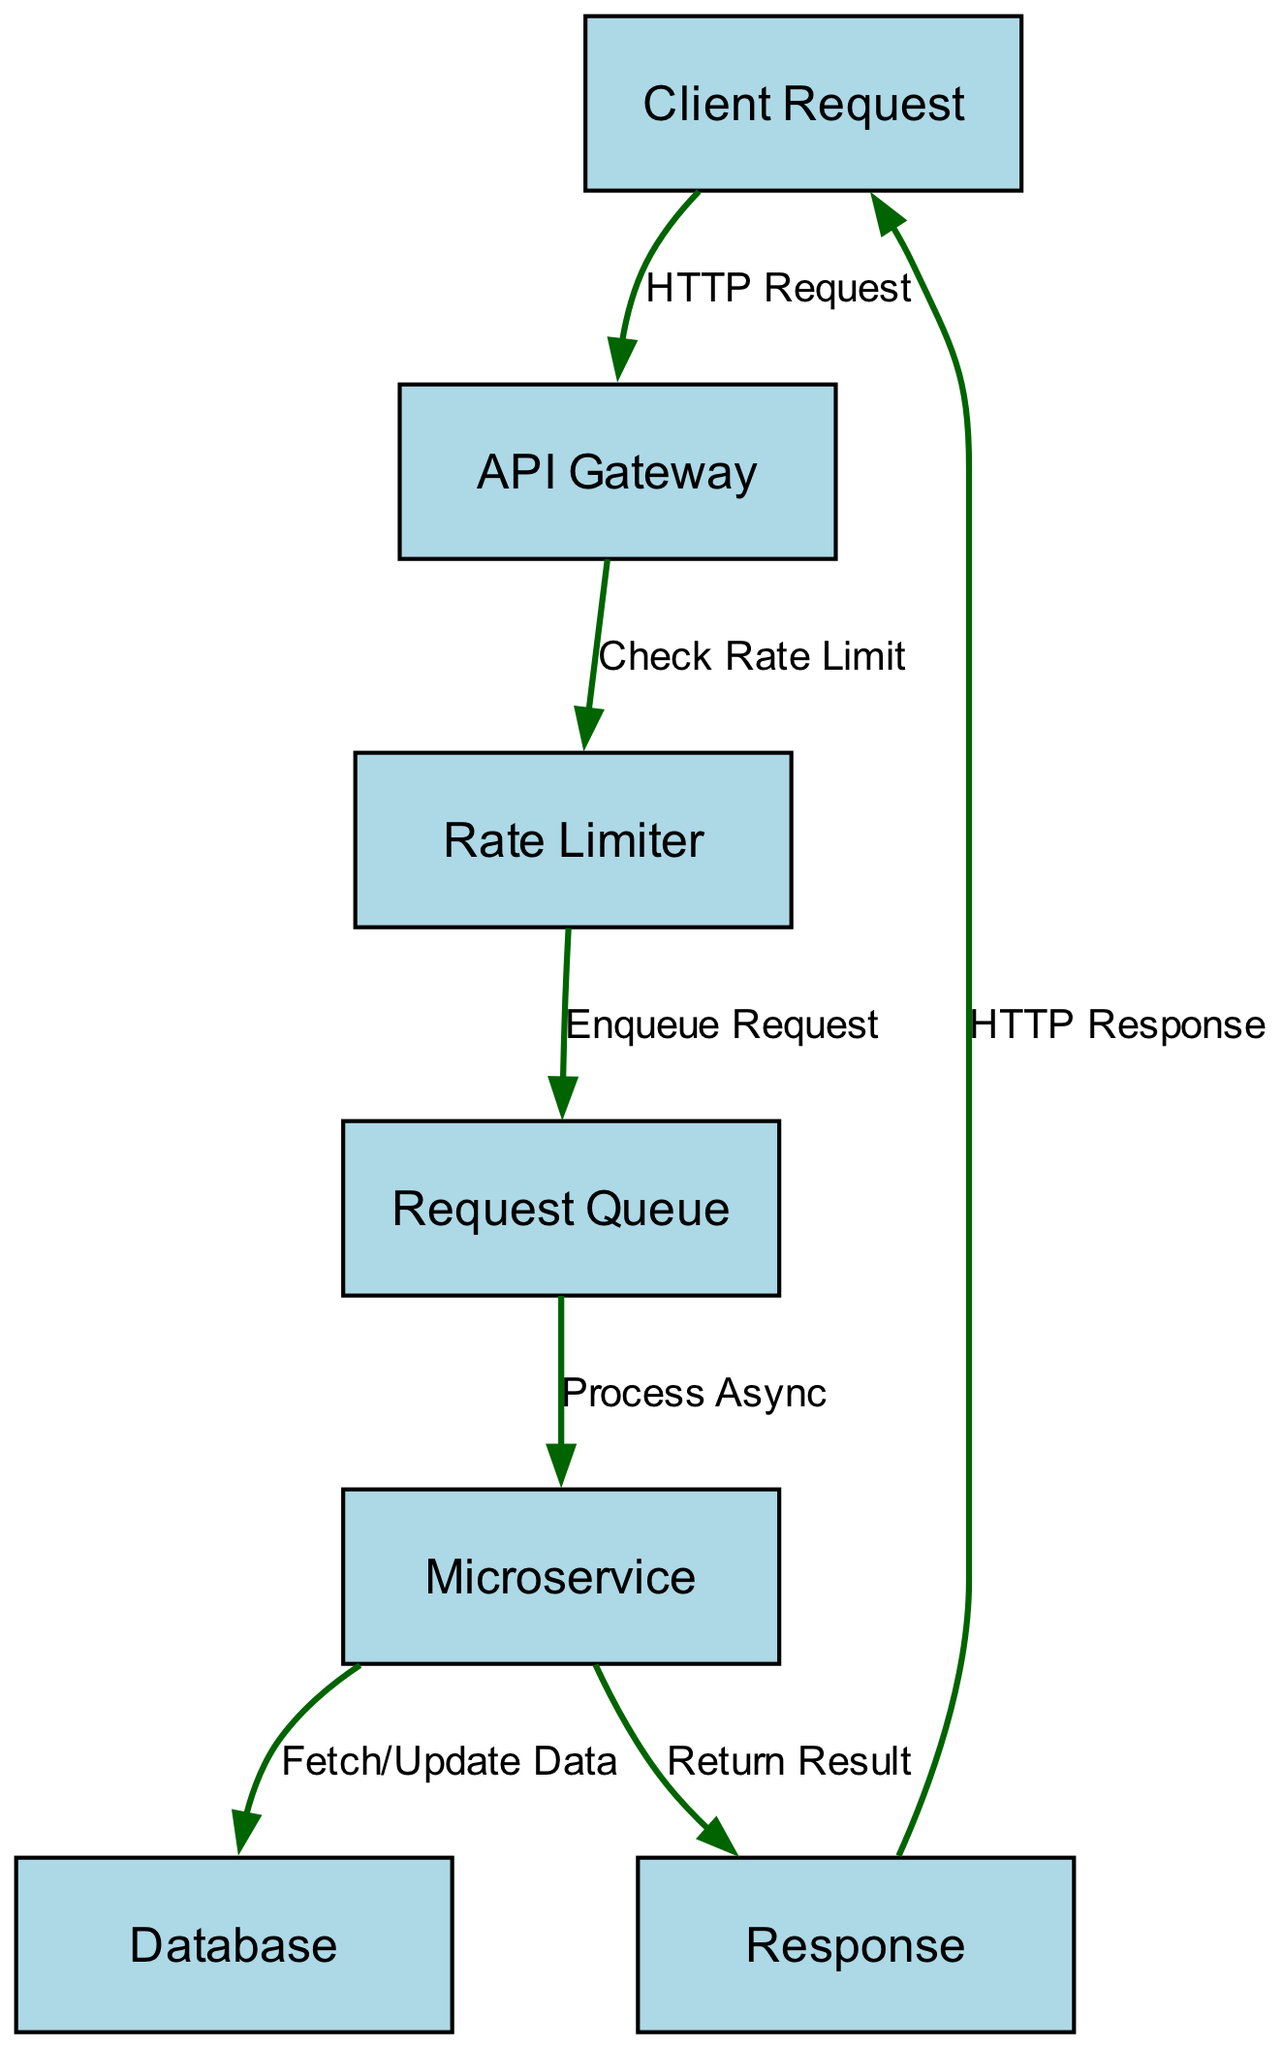What is the first node in the flowchart? The first node in the flowchart is the "Client Request," which is represented as node 1. The flow starts with the client's request for an API service.
Answer: Client Request How many nodes are in the flowchart? The flowchart contains a total of 7 nodes, which are "Client Request," "API Gateway," "Rate Limiter," "Request Queue," "Microservice," "Database," and "Response."
Answer: 7 What does the API Gateway do? The API Gateway’s function is to check the rate limit for incoming requests from clients before proceeding with processing. This is shown by the edge connecting "API Gateway" to "Rate Limiter."
Answer: Check Rate Limit Which node is responsible for processing requests asynchronously? The "Microservice" node is responsible for processing requests asynchronously, as indicated by the edge from the "Request Queue" to the "Microservice."
Answer: Microservice What does the Microservice return after processing? After processing, the Microservice returns a result, which is sent to the "Response" node as indicated by the edge linking "Microservice" to "Response."
Answer: Return Result Which node is the last in the request flow? The last node in the request flow is the "Response," which indicates the final output sent back to the client after all processing has completed.
Answer: Response What happens if the rate limit is exceeded? If the rate limit is exceeded, the request will be enqueued in the "Request Queue" until it can be processed, as shown by the flow returning to the "Rate Limiter" before proceeding to the "Request Queue."
Answer: Enqueue Request How many edges connect the nodes in the flowchart? There are a total of 6 edges connecting the nodes in the flowchart, representing the various relationships and interactions between them.
Answer: 6 What is the purpose of the Database node? The Database node serves as the storage layer for the Microservice, allowing it to fetch or update data as needed when processing requests. This is shown by the edge connecting from "Microservice" to "Database."
Answer: Fetch/Update Data 